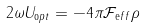<formula> <loc_0><loc_0><loc_500><loc_500>2 \omega U _ { \mathrm o p t } = - 4 \pi { \mathcal { F } } _ { \mathrm e f f } \rho</formula> 